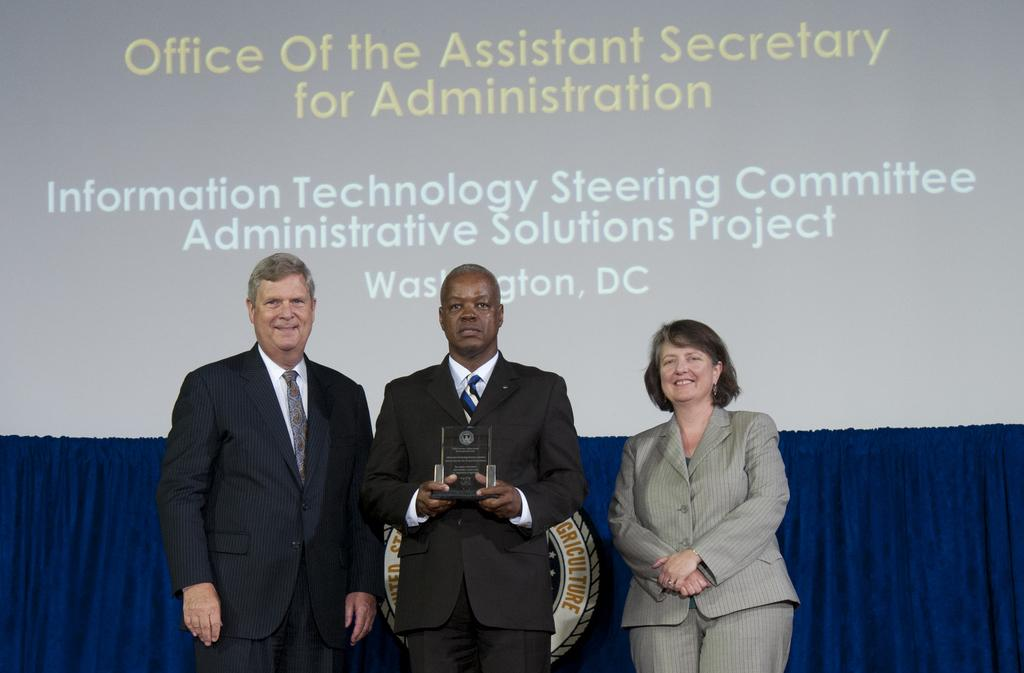How many people are present in the image? There are two men and a woman standing in the image, making a total of three people. What is one of the men holding in the image? One of the men is holding a memento. What can be seen in the background of the image? There is a curtain and a display screen with text visible in the background. What type of stamp can be seen on the mouth of one of the men in the image? There is no stamp visible on the mouth of any of the men in the image. 